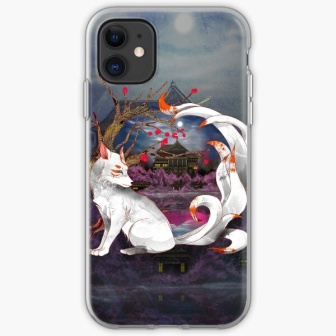What is this photo about? The image presents an intricately designed phone case, showcasing a serene and mystical scene. At the forefront, a regal white fox sits poised, its fur shimmering with intricate details. The fox's long, bushy tail artistically curls around it, resting atop a stylized purple rock. Encircling the fox is a graceful white ribbon, lending an air of elegance and ethereal quality to the design.

The background is a deep, dark blue, featuring a glowing full moon that bathes the environment in a soft, mystical light. Positioned further behind is an enchanting castle, partially obscured by the darkness, adding an element of fantasy and mystery to the scene. Scattered throughout the image are vivid red flowers and branches, contrasting strikingly against the predominant white, purple, and blue tones, enhancing the overall visual appeal.

Each element of the design is meticulously crafted and thoughtfully arranged to create a harmonious and captivating composition, where the white fox serves as the mesmerizing focal point, seamlessly integrated with its enchanting surroundings. 